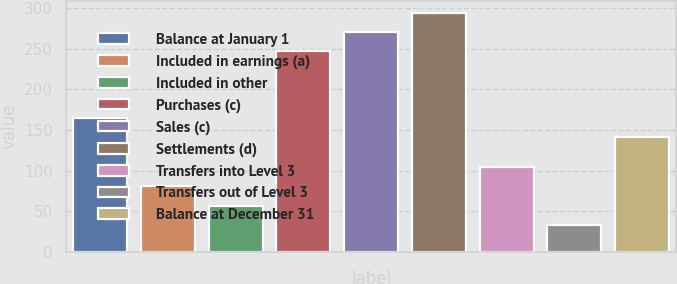<chart> <loc_0><loc_0><loc_500><loc_500><bar_chart><fcel>Balance at January 1<fcel>Included in earnings (a)<fcel>Included in other<fcel>Purchases (c)<fcel>Sales (c)<fcel>Settlements (d)<fcel>Transfers into Level 3<fcel>Transfers out of Level 3<fcel>Balance at December 31<nl><fcel>164.8<fcel>80.6<fcel>56.8<fcel>247<fcel>270.8<fcel>294.6<fcel>104.4<fcel>33<fcel>141<nl></chart> 